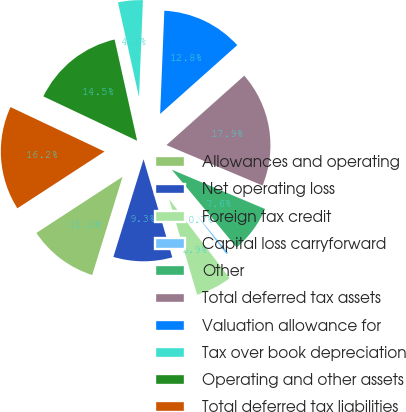Convert chart to OTSL. <chart><loc_0><loc_0><loc_500><loc_500><pie_chart><fcel>Allowances and operating<fcel>Net operating loss<fcel>Foreign tax credit<fcel>Capital loss carryforward<fcel>Other<fcel>Total deferred tax assets<fcel>Valuation allowance for<fcel>Tax over book depreciation<fcel>Operating and other assets<fcel>Total deferred tax liabilities<nl><fcel>11.04%<fcel>9.31%<fcel>5.86%<fcel>0.68%<fcel>7.58%<fcel>17.94%<fcel>12.76%<fcel>4.13%<fcel>14.49%<fcel>16.22%<nl></chart> 